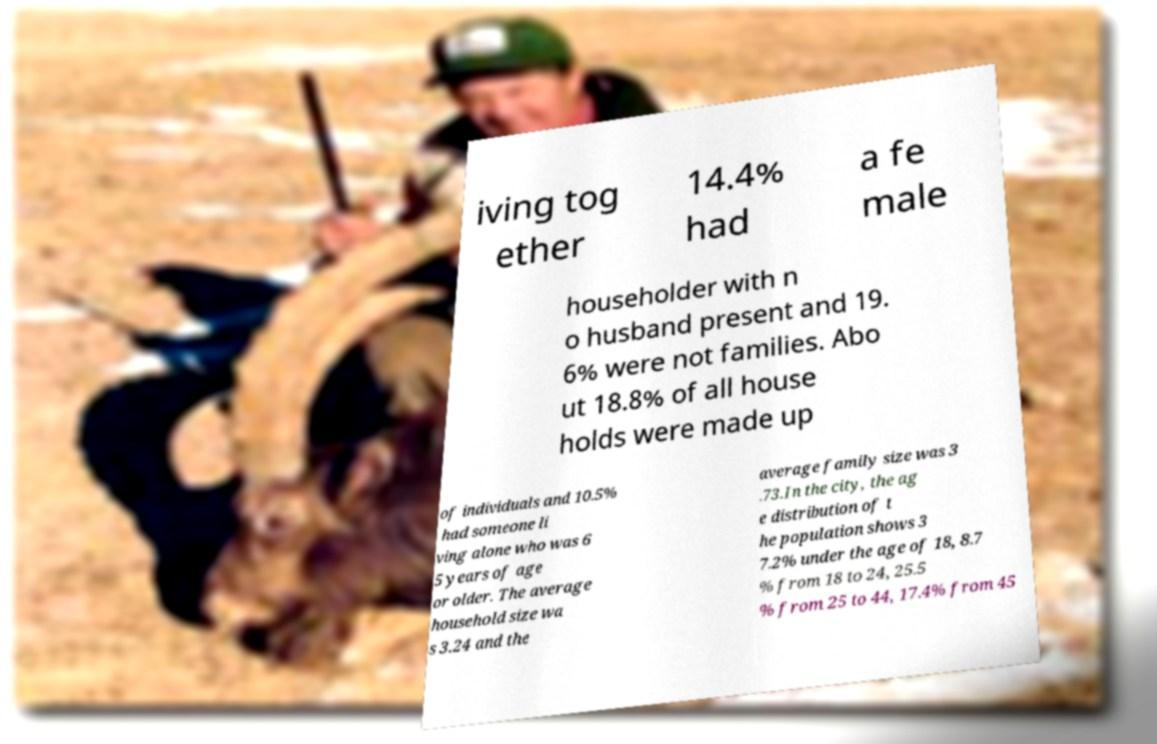There's text embedded in this image that I need extracted. Can you transcribe it verbatim? iving tog ether 14.4% had a fe male householder with n o husband present and 19. 6% were not families. Abo ut 18.8% of all house holds were made up of individuals and 10.5% had someone li ving alone who was 6 5 years of age or older. The average household size wa s 3.24 and the average family size was 3 .73.In the city, the ag e distribution of t he population shows 3 7.2% under the age of 18, 8.7 % from 18 to 24, 25.5 % from 25 to 44, 17.4% from 45 